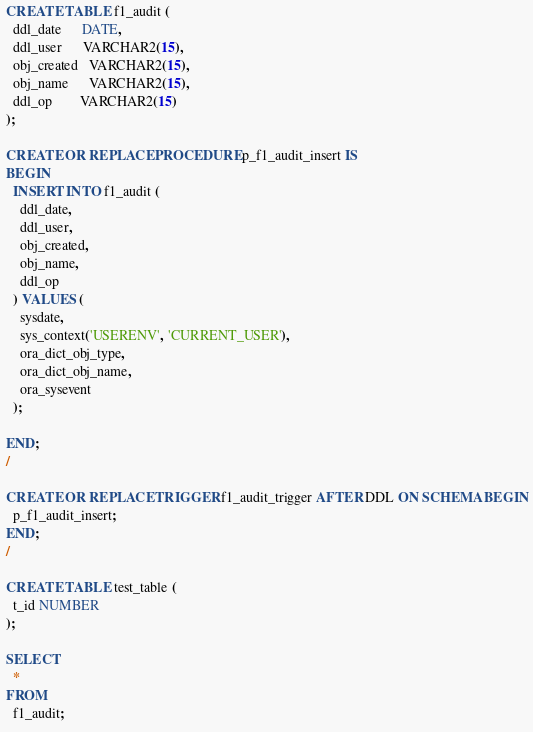Convert code to text. <code><loc_0><loc_0><loc_500><loc_500><_SQL_>CREATE TABLE f1_audit (
  ddl_date      DATE,
  ddl_user      VARCHAR2(15),
  obj_created   VARCHAR2(15),
  obj_name      VARCHAR2(15),
  ddl_op        VARCHAR2(15)
);

CREATE OR REPLACE PROCEDURE p_f1_audit_insert IS
BEGIN
  INSERT INTO f1_audit (
    ddl_date,
    ddl_user,
    obj_created,
    obj_name,
    ddl_op
  ) VALUES (
    sysdate,
    sys_context('USERENV', 'CURRENT_USER'),
    ora_dict_obj_type,
    ora_dict_obj_name,
    ora_sysevent
  );

END;
/

CREATE OR REPLACE TRIGGER f1_audit_trigger AFTER DDL ON SCHEMA BEGIN
  p_f1_audit_insert;
END;
/

CREATE TABLE test_table (
  t_id NUMBER
);

SELECT
  *
FROM
  f1_audit;
</code> 